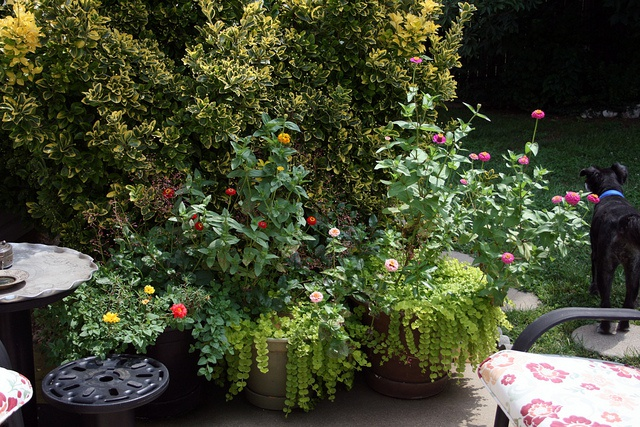Describe the objects in this image and their specific colors. I can see potted plant in black and darkgreen tones, potted plant in black, darkgreen, and olive tones, potted plant in black and darkgreen tones, chair in black, white, and lightpink tones, and potted plant in black, darkgreen, and olive tones in this image. 